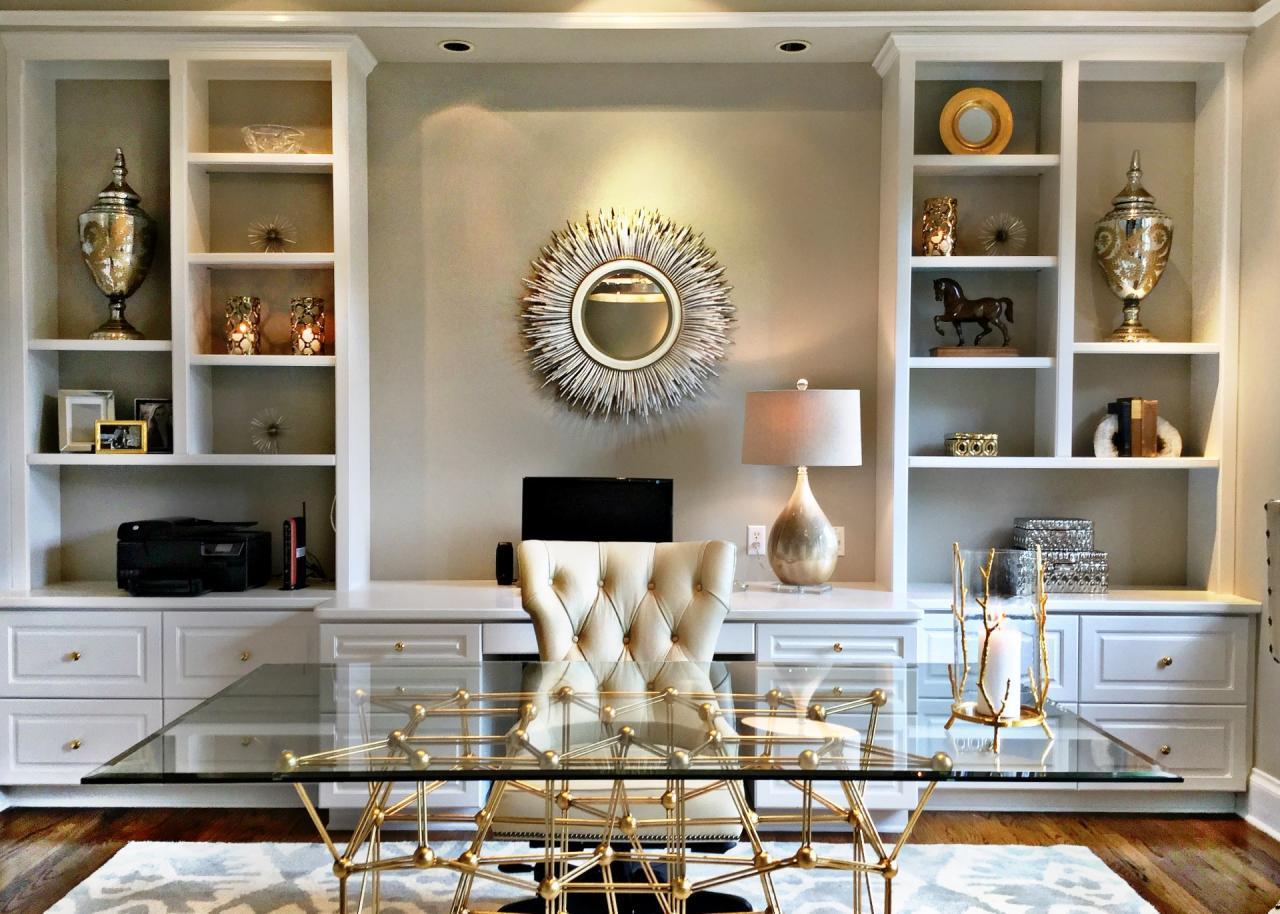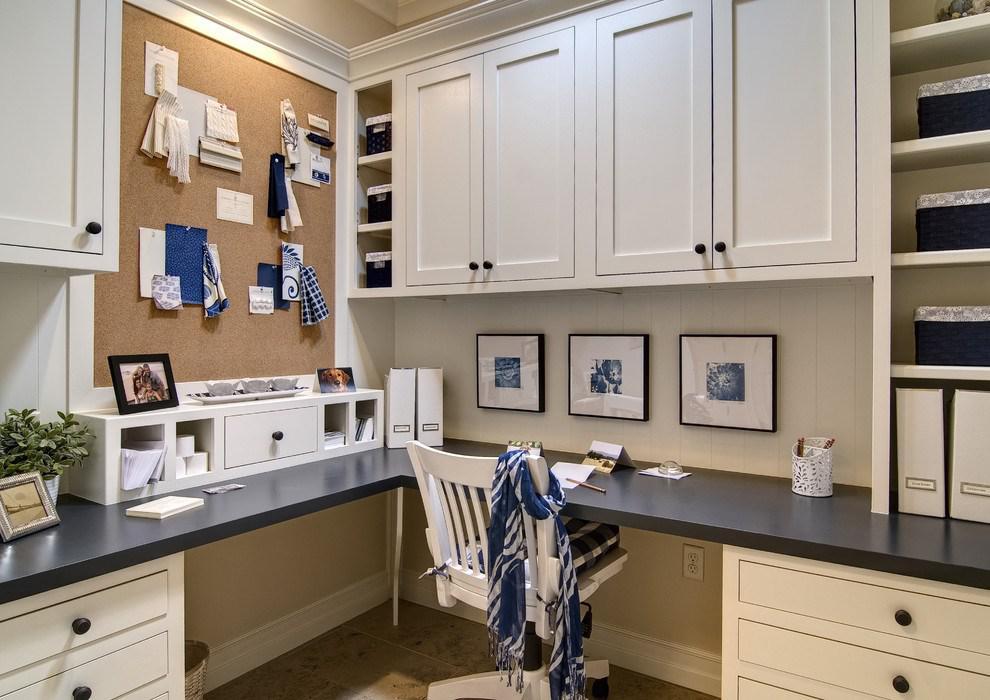The first image is the image on the left, the second image is the image on the right. Examine the images to the left and right. Is the description "In one image, a large white shelving unit has solid panel doors at the bottom, open shelves at the top, and a television in the center position." accurate? Answer yes or no. No. The first image is the image on the left, the second image is the image on the right. Assess this claim about the two images: "A room with a built-in bookcase also features a 'gravity defying' item of decor utilizing negative space.". Correct or not? Answer yes or no. Yes. 